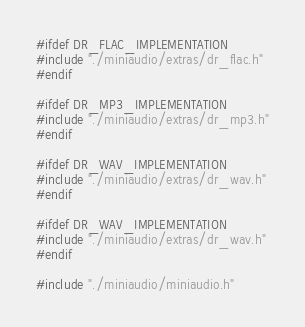Convert code to text. <code><loc_0><loc_0><loc_500><loc_500><_C_>#ifdef DR_FLAC_IMPLEMENTATION
#include "./miniaudio/extras/dr_flac.h"
#endif

#ifdef DR_MP3_IMPLEMENTATION
#include "./miniaudio/extras/dr_mp3.h"
#endif

#ifdef DR_WAV_IMPLEMENTATION
#include "./miniaudio/extras/dr_wav.h"
#endif

#ifdef DR_WAV_IMPLEMENTATION
#include "./miniaudio/extras/dr_wav.h"
#endif

#include "./miniaudio/miniaudio.h"
</code> 